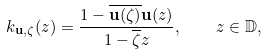Convert formula to latex. <formula><loc_0><loc_0><loc_500><loc_500>k _ { { \mathbf u } , \zeta } ( z ) = \frac { 1 - \overline { { \mathbf u } ( \zeta ) } { \mathbf u } ( z ) } { 1 - \overline { \zeta } z } , \quad z \in \mathbb { D } ,</formula> 